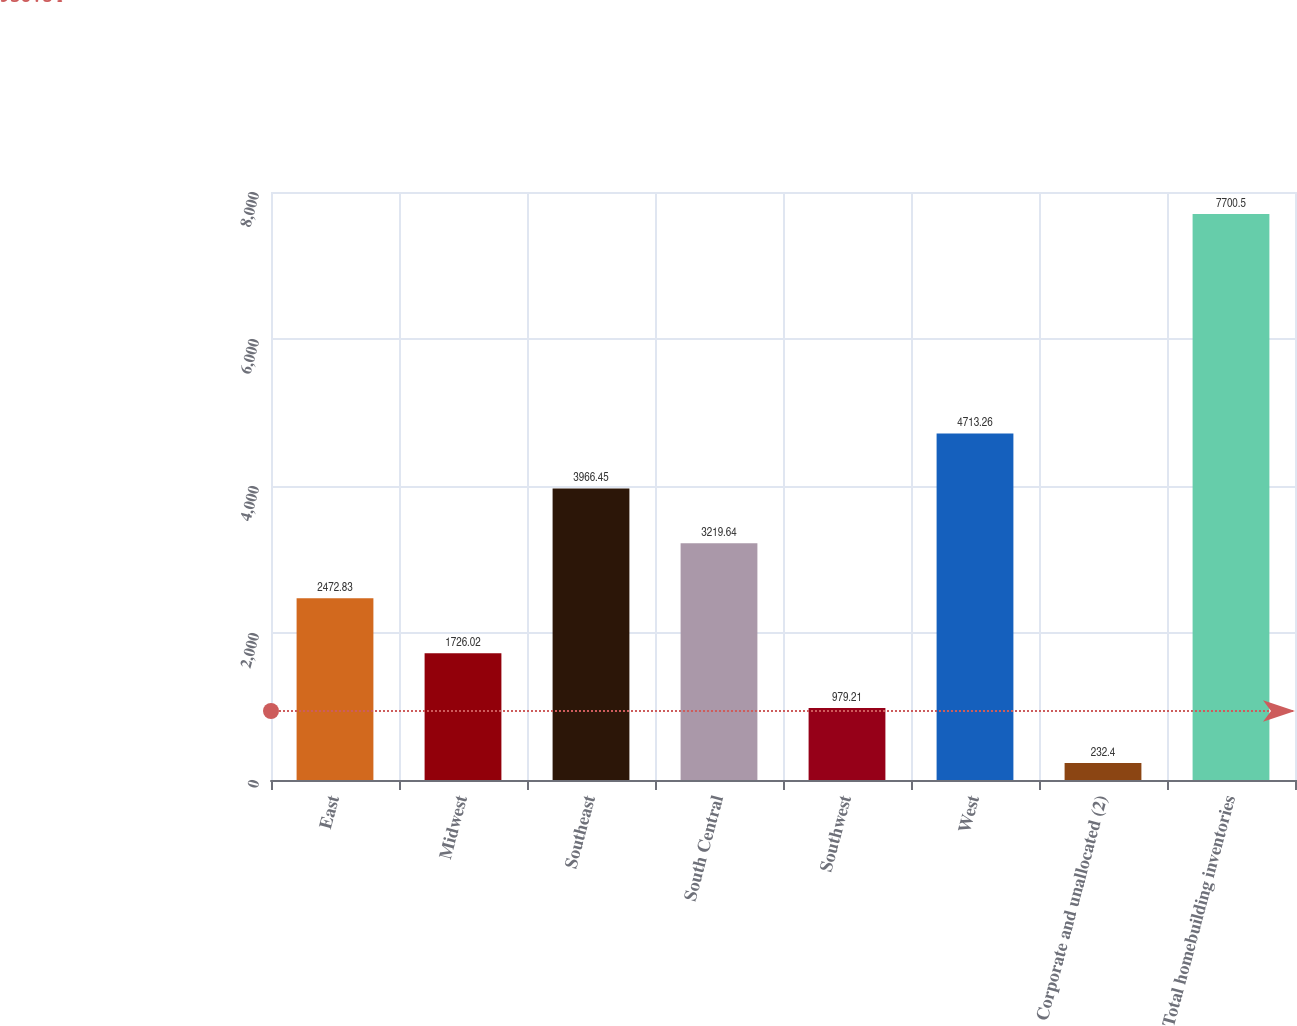Convert chart. <chart><loc_0><loc_0><loc_500><loc_500><bar_chart><fcel>East<fcel>Midwest<fcel>Southeast<fcel>South Central<fcel>Southwest<fcel>West<fcel>Corporate and unallocated (2)<fcel>Total homebuilding inventories<nl><fcel>2472.83<fcel>1726.02<fcel>3966.45<fcel>3219.64<fcel>979.21<fcel>4713.26<fcel>232.4<fcel>7700.5<nl></chart> 